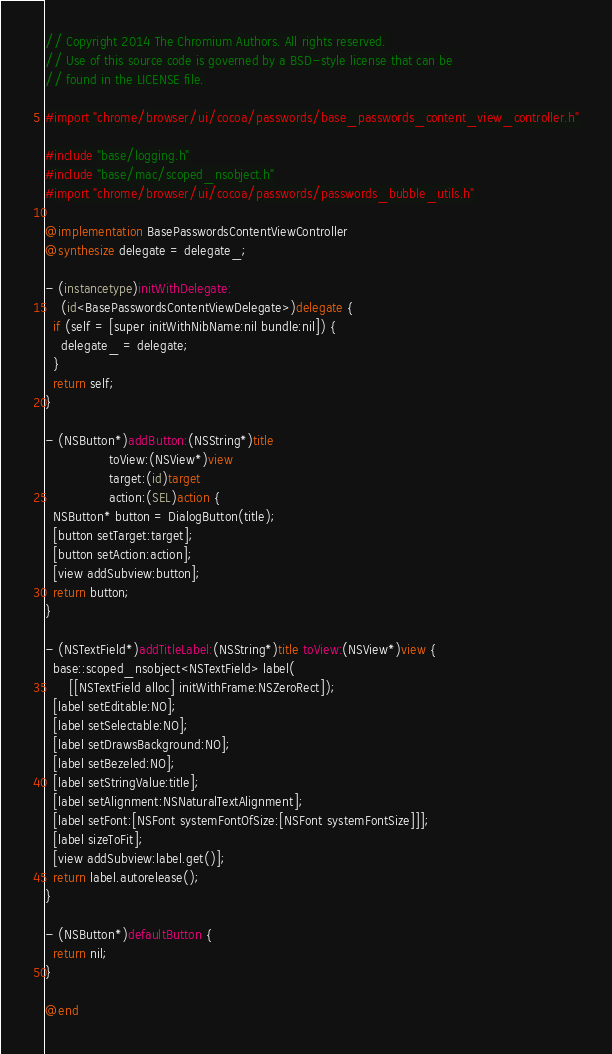Convert code to text. <code><loc_0><loc_0><loc_500><loc_500><_ObjectiveC_>// Copyright 2014 The Chromium Authors. All rights reserved.
// Use of this source code is governed by a BSD-style license that can be
// found in the LICENSE file.

#import "chrome/browser/ui/cocoa/passwords/base_passwords_content_view_controller.h"

#include "base/logging.h"
#include "base/mac/scoped_nsobject.h"
#import "chrome/browser/ui/cocoa/passwords/passwords_bubble_utils.h"

@implementation BasePasswordsContentViewController
@synthesize delegate = delegate_;

- (instancetype)initWithDelegate:
    (id<BasePasswordsContentViewDelegate>)delegate {
  if (self = [super initWithNibName:nil bundle:nil]) {
    delegate_ = delegate;
  }
  return self;
}

- (NSButton*)addButton:(NSString*)title
                toView:(NSView*)view
                target:(id)target
                action:(SEL)action {
  NSButton* button = DialogButton(title);
  [button setTarget:target];
  [button setAction:action];
  [view addSubview:button];
  return button;
}

- (NSTextField*)addTitleLabel:(NSString*)title toView:(NSView*)view {
  base::scoped_nsobject<NSTextField> label(
      [[NSTextField alloc] initWithFrame:NSZeroRect]);
  [label setEditable:NO];
  [label setSelectable:NO];
  [label setDrawsBackground:NO];
  [label setBezeled:NO];
  [label setStringValue:title];
  [label setAlignment:NSNaturalTextAlignment];
  [label setFont:[NSFont systemFontOfSize:[NSFont systemFontSize]]];
  [label sizeToFit];
  [view addSubview:label.get()];
  return label.autorelease();
}

- (NSButton*)defaultButton {
  return nil;
}

@end
</code> 